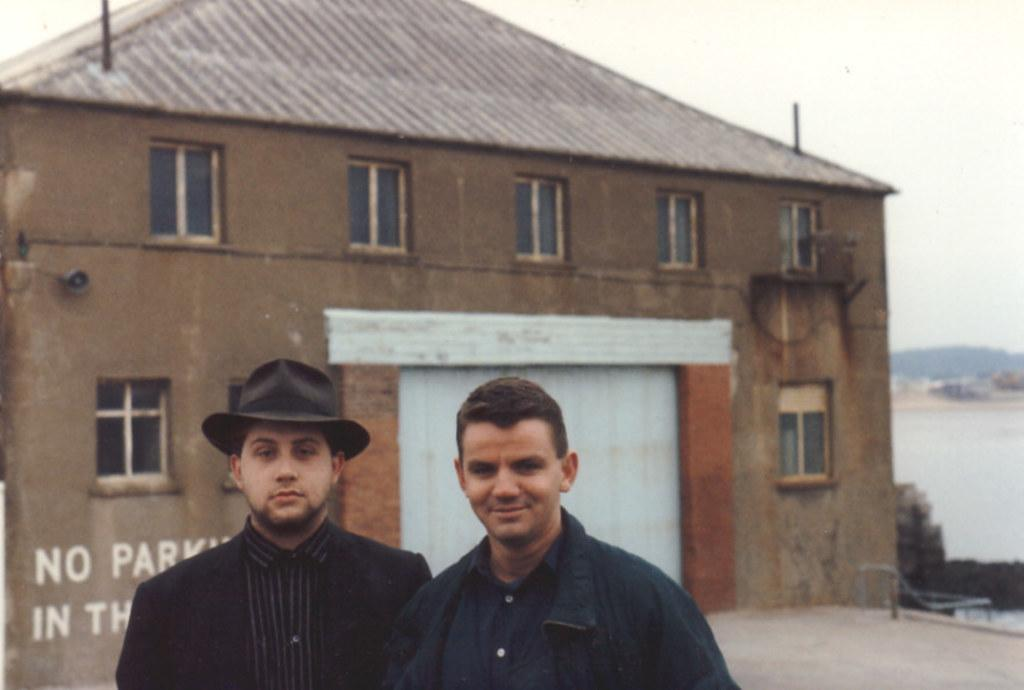How many people are in the foreground of the image? There are two people standing in the foreground of the image. Can you describe the clothing or accessories of one of the people? One person is wearing a cap. What can be seen in the background of the image? There is a house in the background of the image. What type of bone can be seen in the image? There is no bone present in the image; it features two people standing in the foreground and a house in the background. 